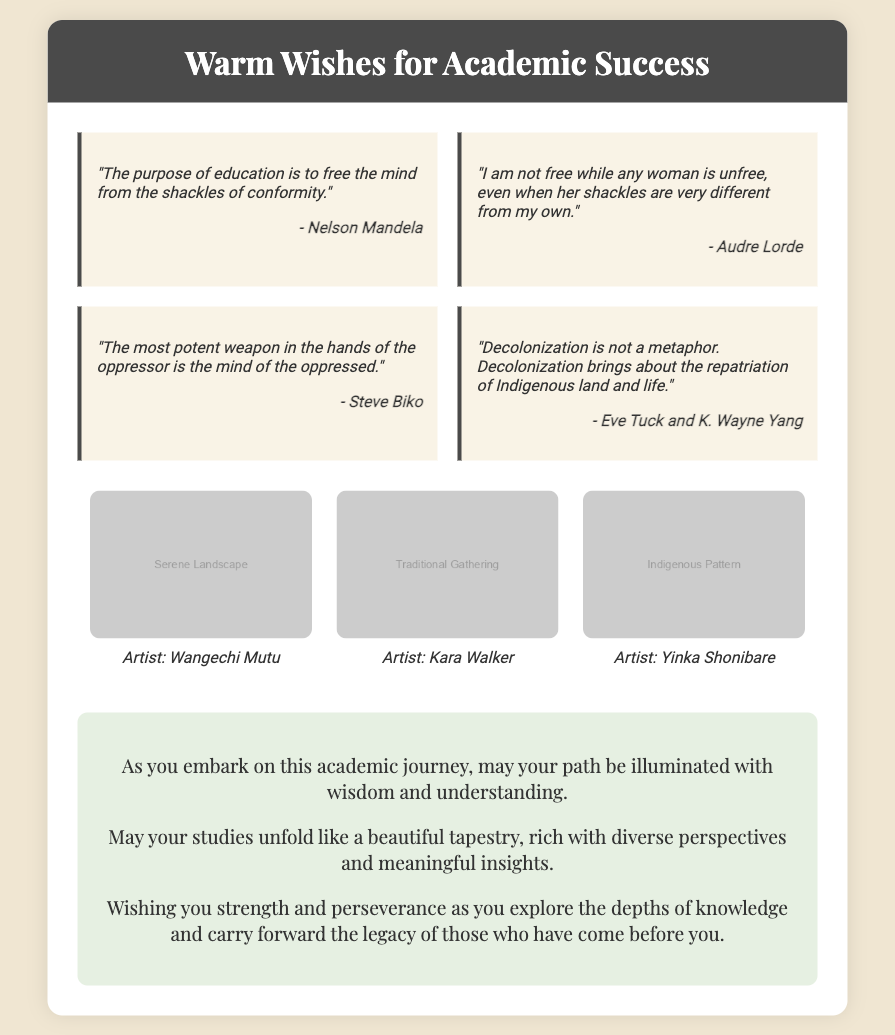What is the title of the card? The title is found in the card-header section, which prominently displays the phrase.
Answer: Warm Wishes for Academic Success Who is the first author quoted in the card? The first quote is provided in the quotes section along with the author's name.
Answer: Nelson Mandela How many illustrations are included in the card? The illustrations section contains three distinct images.
Answer: 3 What theme do the illustrations represent? The illustrations are related to the broader themes echoed in the quotes about education and decolonization.
Answer: Diverse perspectives Which quote suggests a connection between education and freedom? This quote explicitly mentions the purpose of education in relation to conformity.
Answer: "The purpose of education is to free the mind from the shackles of conformity." What is the profession of the person who receives the card? The card is designed for someone embarking on an academic journey, implying they are a student or scholar.
Answer: Student Who is the artist of the "Indigenous Pattern" illustration? The artist's name is included under the respective illustration.
Answer: Yinka Shonibare What type of wishes does the card convey? The wishes provided in the card emphasize encouragement and support for academic pursuits.
Answer: Warm wishes for academic success 